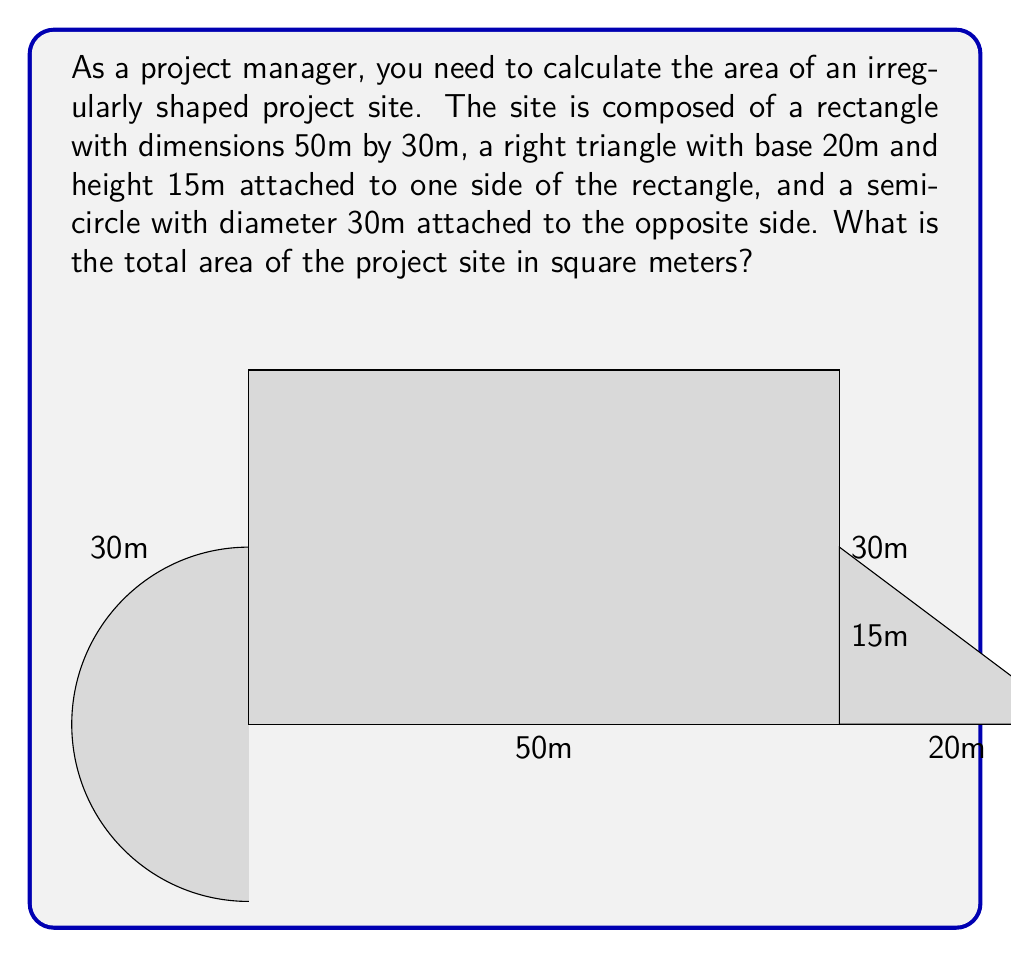Can you answer this question? To calculate the total area of the project site, we need to sum the areas of the rectangle, right triangle, and semicircle.

1. Area of the rectangle:
   $A_r = l \times w = 50\text{m} \times 30\text{m} = 1500\text{m}^2$

2. Area of the right triangle:
   $A_t = \frac{1}{2} \times b \times h = \frac{1}{2} \times 20\text{m} \times 15\text{m} = 150\text{m}^2$

3. Area of the semicircle:
   The diameter is 30m, so the radius is 15m.
   $A_s = \frac{1}{2} \times \pi r^2 = \frac{1}{2} \times \pi \times (15\text{m})^2 = \frac{1}{2} \times \pi \times 225\text{m}^2 = 353.43\text{m}^2$

4. Total area:
   $A_{\text{total}} = A_r + A_t + A_s = 1500\text{m}^2 + 150\text{m}^2 + 353.43\text{m}^2 = 2003.43\text{m}^2$

Therefore, the total area of the project site is approximately 2003.43 square meters.
Answer: $2003.43\text{m}^2$ 